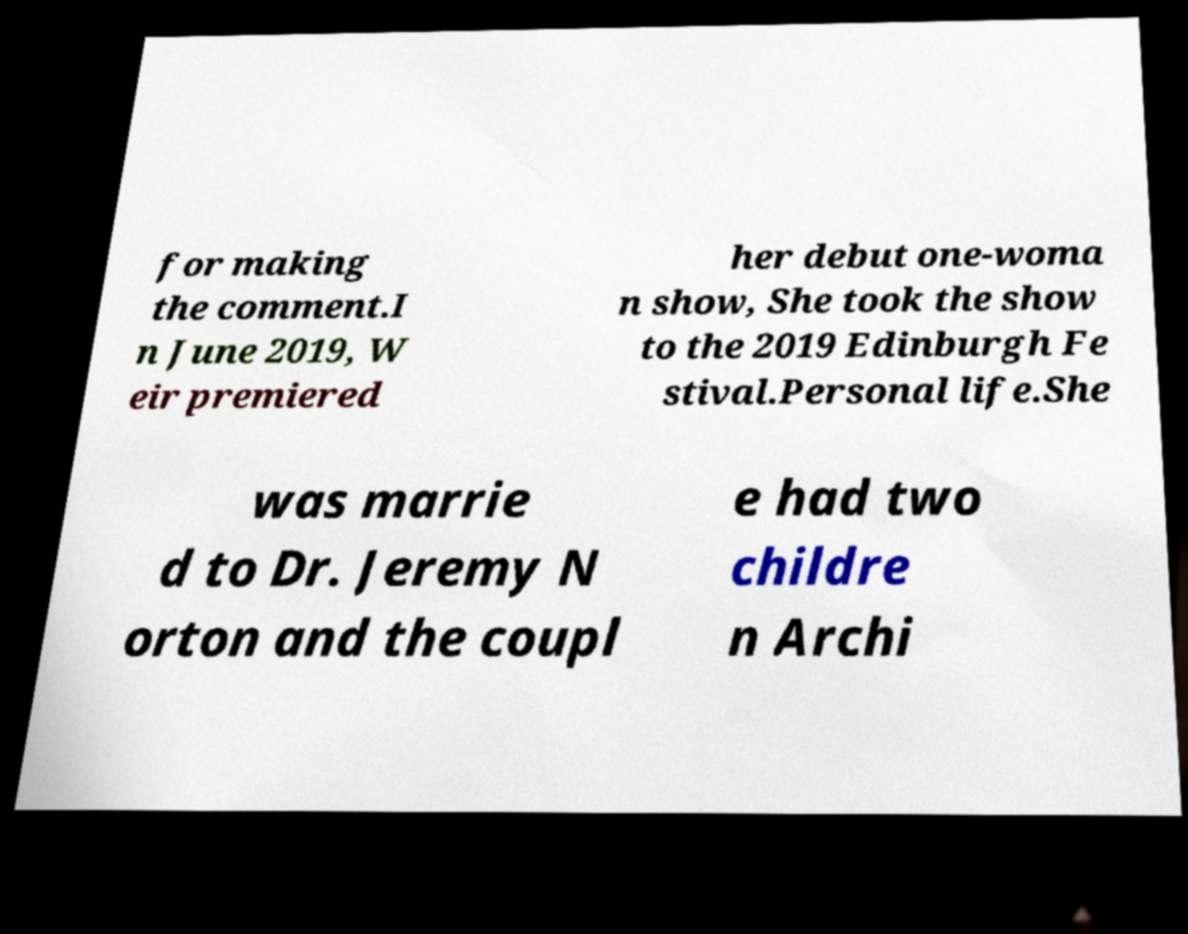Could you extract and type out the text from this image? for making the comment.I n June 2019, W eir premiered her debut one-woma n show, She took the show to the 2019 Edinburgh Fe stival.Personal life.She was marrie d to Dr. Jeremy N orton and the coupl e had two childre n Archi 